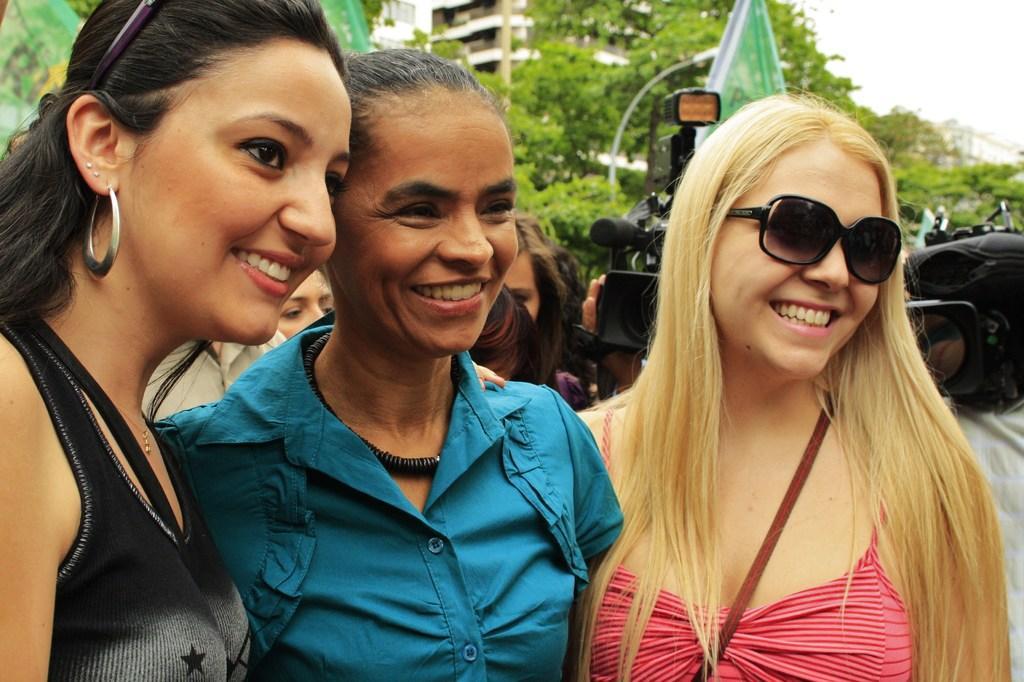Describe this image in one or two sentences. In this image I can see in the middle three girls are smiling, they are wearing dresses. On the right side few persons are holding the cameras. In the background there are trees and buildings. 